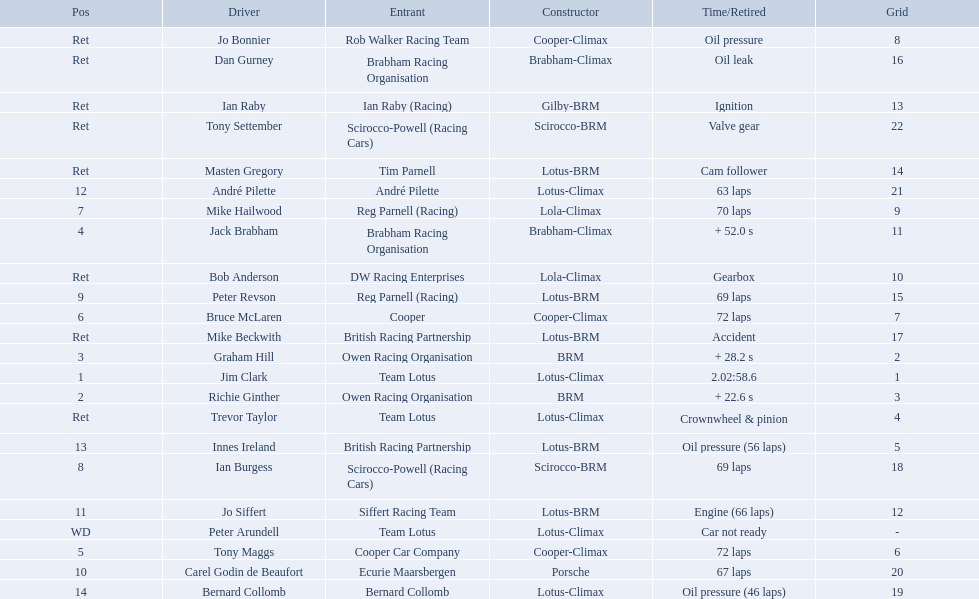What are the listed driver names? Jim Clark, Richie Ginther, Graham Hill, Jack Brabham, Tony Maggs, Bruce McLaren, Mike Hailwood, Ian Burgess, Peter Revson, Carel Godin de Beaufort, Jo Siffert, André Pilette, Innes Ireland, Bernard Collomb, Ian Raby, Dan Gurney, Mike Beckwith, Masten Gregory, Trevor Taylor, Jo Bonnier, Tony Settember, Bob Anderson, Peter Arundell. Which are tony maggs and jo siffert? Tony Maggs, Jo Siffert. What are their corresponding finishing places? 5, 11. Whose is better? Tony Maggs. 